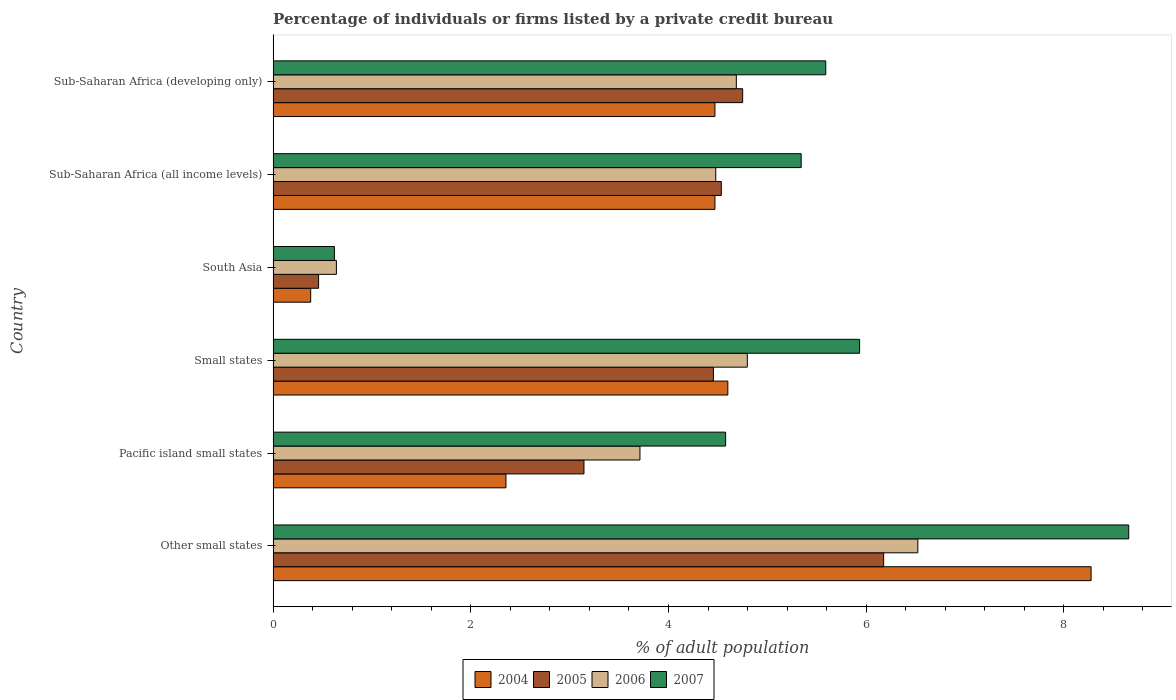How many groups of bars are there?
Your answer should be very brief. 6. How many bars are there on the 4th tick from the top?
Your answer should be compact. 4. What is the label of the 2nd group of bars from the top?
Keep it short and to the point. Sub-Saharan Africa (all income levels). In how many cases, is the number of bars for a given country not equal to the number of legend labels?
Ensure brevity in your answer.  0. What is the percentage of population listed by a private credit bureau in 2005 in Pacific island small states?
Provide a short and direct response. 3.14. Across all countries, what is the maximum percentage of population listed by a private credit bureau in 2007?
Ensure brevity in your answer.  8.66. Across all countries, what is the minimum percentage of population listed by a private credit bureau in 2007?
Your response must be concise. 0.62. In which country was the percentage of population listed by a private credit bureau in 2004 maximum?
Give a very brief answer. Other small states. In which country was the percentage of population listed by a private credit bureau in 2006 minimum?
Give a very brief answer. South Asia. What is the total percentage of population listed by a private credit bureau in 2006 in the graph?
Your answer should be compact. 24.83. What is the difference between the percentage of population listed by a private credit bureau in 2004 in Other small states and that in Sub-Saharan Africa (all income levels)?
Offer a very short reply. 3.81. What is the difference between the percentage of population listed by a private credit bureau in 2005 in Pacific island small states and the percentage of population listed by a private credit bureau in 2007 in Sub-Saharan Africa (developing only)?
Make the answer very short. -2.45. What is the average percentage of population listed by a private credit bureau in 2004 per country?
Give a very brief answer. 4.09. What is the difference between the percentage of population listed by a private credit bureau in 2007 and percentage of population listed by a private credit bureau in 2004 in Small states?
Ensure brevity in your answer.  1.33. What is the ratio of the percentage of population listed by a private credit bureau in 2007 in Sub-Saharan Africa (all income levels) to that in Sub-Saharan Africa (developing only)?
Your answer should be compact. 0.96. What is the difference between the highest and the second highest percentage of population listed by a private credit bureau in 2006?
Give a very brief answer. 1.72. What is the difference between the highest and the lowest percentage of population listed by a private credit bureau in 2007?
Provide a short and direct response. 8.04. Is the sum of the percentage of population listed by a private credit bureau in 2006 in Small states and Sub-Saharan Africa (all income levels) greater than the maximum percentage of population listed by a private credit bureau in 2005 across all countries?
Make the answer very short. Yes. Is it the case that in every country, the sum of the percentage of population listed by a private credit bureau in 2004 and percentage of population listed by a private credit bureau in 2007 is greater than the sum of percentage of population listed by a private credit bureau in 2006 and percentage of population listed by a private credit bureau in 2005?
Your answer should be compact. No. How many bars are there?
Offer a terse response. 24. How many countries are there in the graph?
Offer a very short reply. 6. What is the difference between two consecutive major ticks on the X-axis?
Ensure brevity in your answer.  2. Does the graph contain any zero values?
Your answer should be very brief. No. Where does the legend appear in the graph?
Give a very brief answer. Bottom center. How are the legend labels stacked?
Provide a short and direct response. Horizontal. What is the title of the graph?
Offer a very short reply. Percentage of individuals or firms listed by a private credit bureau. What is the label or title of the X-axis?
Offer a terse response. % of adult population. What is the % of adult population in 2004 in Other small states?
Ensure brevity in your answer.  8.28. What is the % of adult population in 2005 in Other small states?
Ensure brevity in your answer.  6.18. What is the % of adult population in 2006 in Other small states?
Your response must be concise. 6.52. What is the % of adult population in 2007 in Other small states?
Give a very brief answer. 8.66. What is the % of adult population of 2004 in Pacific island small states?
Your answer should be very brief. 2.36. What is the % of adult population of 2005 in Pacific island small states?
Give a very brief answer. 3.14. What is the % of adult population in 2006 in Pacific island small states?
Provide a short and direct response. 3.71. What is the % of adult population of 2007 in Pacific island small states?
Ensure brevity in your answer.  4.58. What is the % of adult population in 2004 in Small states?
Make the answer very short. 4.6. What is the % of adult population of 2005 in Small states?
Give a very brief answer. 4.45. What is the % of adult population of 2006 in Small states?
Provide a short and direct response. 4.8. What is the % of adult population in 2007 in Small states?
Your answer should be compact. 5.93. What is the % of adult population of 2004 in South Asia?
Your response must be concise. 0.38. What is the % of adult population of 2005 in South Asia?
Provide a succinct answer. 0.46. What is the % of adult population of 2006 in South Asia?
Ensure brevity in your answer.  0.64. What is the % of adult population of 2007 in South Asia?
Make the answer very short. 0.62. What is the % of adult population of 2004 in Sub-Saharan Africa (all income levels)?
Ensure brevity in your answer.  4.47. What is the % of adult population of 2005 in Sub-Saharan Africa (all income levels)?
Offer a very short reply. 4.53. What is the % of adult population in 2006 in Sub-Saharan Africa (all income levels)?
Your answer should be compact. 4.48. What is the % of adult population of 2007 in Sub-Saharan Africa (all income levels)?
Your answer should be very brief. 5.34. What is the % of adult population in 2004 in Sub-Saharan Africa (developing only)?
Provide a succinct answer. 4.47. What is the % of adult population of 2005 in Sub-Saharan Africa (developing only)?
Offer a terse response. 4.75. What is the % of adult population in 2006 in Sub-Saharan Africa (developing only)?
Make the answer very short. 4.69. What is the % of adult population of 2007 in Sub-Saharan Africa (developing only)?
Provide a short and direct response. 5.59. Across all countries, what is the maximum % of adult population in 2004?
Offer a terse response. 8.28. Across all countries, what is the maximum % of adult population of 2005?
Offer a terse response. 6.18. Across all countries, what is the maximum % of adult population of 2006?
Make the answer very short. 6.52. Across all countries, what is the maximum % of adult population of 2007?
Ensure brevity in your answer.  8.66. Across all countries, what is the minimum % of adult population of 2004?
Your answer should be very brief. 0.38. Across all countries, what is the minimum % of adult population of 2005?
Offer a terse response. 0.46. Across all countries, what is the minimum % of adult population of 2006?
Give a very brief answer. 0.64. Across all countries, what is the minimum % of adult population in 2007?
Keep it short and to the point. 0.62. What is the total % of adult population of 2004 in the graph?
Your response must be concise. 24.55. What is the total % of adult population of 2005 in the graph?
Provide a short and direct response. 23.52. What is the total % of adult population of 2006 in the graph?
Give a very brief answer. 24.83. What is the total % of adult population in 2007 in the graph?
Keep it short and to the point. 30.72. What is the difference between the % of adult population in 2004 in Other small states and that in Pacific island small states?
Keep it short and to the point. 5.92. What is the difference between the % of adult population in 2005 in Other small states and that in Pacific island small states?
Provide a succinct answer. 3.03. What is the difference between the % of adult population in 2006 in Other small states and that in Pacific island small states?
Provide a succinct answer. 2.81. What is the difference between the % of adult population of 2007 in Other small states and that in Pacific island small states?
Make the answer very short. 4.08. What is the difference between the % of adult population of 2004 in Other small states and that in Small states?
Your response must be concise. 3.67. What is the difference between the % of adult population of 2005 in Other small states and that in Small states?
Give a very brief answer. 1.72. What is the difference between the % of adult population in 2006 in Other small states and that in Small states?
Your answer should be very brief. 1.72. What is the difference between the % of adult population in 2007 in Other small states and that in Small states?
Provide a short and direct response. 2.72. What is the difference between the % of adult population in 2004 in Other small states and that in South Asia?
Provide a succinct answer. 7.89. What is the difference between the % of adult population of 2005 in Other small states and that in South Asia?
Your answer should be compact. 5.72. What is the difference between the % of adult population of 2006 in Other small states and that in South Asia?
Offer a very short reply. 5.88. What is the difference between the % of adult population of 2007 in Other small states and that in South Asia?
Provide a succinct answer. 8.04. What is the difference between the % of adult population in 2004 in Other small states and that in Sub-Saharan Africa (all income levels)?
Make the answer very short. 3.81. What is the difference between the % of adult population in 2005 in Other small states and that in Sub-Saharan Africa (all income levels)?
Your answer should be compact. 1.64. What is the difference between the % of adult population of 2006 in Other small states and that in Sub-Saharan Africa (all income levels)?
Offer a terse response. 2.04. What is the difference between the % of adult population of 2007 in Other small states and that in Sub-Saharan Africa (all income levels)?
Your answer should be very brief. 3.31. What is the difference between the % of adult population of 2004 in Other small states and that in Sub-Saharan Africa (developing only)?
Keep it short and to the point. 3.81. What is the difference between the % of adult population in 2005 in Other small states and that in Sub-Saharan Africa (developing only)?
Give a very brief answer. 1.43. What is the difference between the % of adult population in 2006 in Other small states and that in Sub-Saharan Africa (developing only)?
Your response must be concise. 1.84. What is the difference between the % of adult population in 2007 in Other small states and that in Sub-Saharan Africa (developing only)?
Give a very brief answer. 3.06. What is the difference between the % of adult population in 2004 in Pacific island small states and that in Small states?
Provide a succinct answer. -2.24. What is the difference between the % of adult population of 2005 in Pacific island small states and that in Small states?
Ensure brevity in your answer.  -1.31. What is the difference between the % of adult population in 2006 in Pacific island small states and that in Small states?
Your response must be concise. -1.09. What is the difference between the % of adult population of 2007 in Pacific island small states and that in Small states?
Keep it short and to the point. -1.36. What is the difference between the % of adult population of 2004 in Pacific island small states and that in South Asia?
Provide a short and direct response. 1.98. What is the difference between the % of adult population in 2005 in Pacific island small states and that in South Asia?
Make the answer very short. 2.68. What is the difference between the % of adult population in 2006 in Pacific island small states and that in South Asia?
Offer a very short reply. 3.07. What is the difference between the % of adult population of 2007 in Pacific island small states and that in South Asia?
Provide a short and direct response. 3.96. What is the difference between the % of adult population of 2004 in Pacific island small states and that in Sub-Saharan Africa (all income levels)?
Give a very brief answer. -2.11. What is the difference between the % of adult population in 2005 in Pacific island small states and that in Sub-Saharan Africa (all income levels)?
Ensure brevity in your answer.  -1.39. What is the difference between the % of adult population in 2006 in Pacific island small states and that in Sub-Saharan Africa (all income levels)?
Ensure brevity in your answer.  -0.77. What is the difference between the % of adult population in 2007 in Pacific island small states and that in Sub-Saharan Africa (all income levels)?
Provide a succinct answer. -0.76. What is the difference between the % of adult population in 2004 in Pacific island small states and that in Sub-Saharan Africa (developing only)?
Keep it short and to the point. -2.11. What is the difference between the % of adult population of 2005 in Pacific island small states and that in Sub-Saharan Africa (developing only)?
Keep it short and to the point. -1.61. What is the difference between the % of adult population of 2006 in Pacific island small states and that in Sub-Saharan Africa (developing only)?
Keep it short and to the point. -0.97. What is the difference between the % of adult population of 2007 in Pacific island small states and that in Sub-Saharan Africa (developing only)?
Your response must be concise. -1.01. What is the difference between the % of adult population in 2004 in Small states and that in South Asia?
Offer a terse response. 4.22. What is the difference between the % of adult population in 2005 in Small states and that in South Asia?
Your response must be concise. 3.99. What is the difference between the % of adult population in 2006 in Small states and that in South Asia?
Give a very brief answer. 4.16. What is the difference between the % of adult population in 2007 in Small states and that in South Asia?
Your response must be concise. 5.31. What is the difference between the % of adult population of 2004 in Small states and that in Sub-Saharan Africa (all income levels)?
Ensure brevity in your answer.  0.13. What is the difference between the % of adult population of 2005 in Small states and that in Sub-Saharan Africa (all income levels)?
Your response must be concise. -0.08. What is the difference between the % of adult population in 2006 in Small states and that in Sub-Saharan Africa (all income levels)?
Keep it short and to the point. 0.32. What is the difference between the % of adult population of 2007 in Small states and that in Sub-Saharan Africa (all income levels)?
Your response must be concise. 0.59. What is the difference between the % of adult population in 2004 in Small states and that in Sub-Saharan Africa (developing only)?
Offer a very short reply. 0.13. What is the difference between the % of adult population of 2005 in Small states and that in Sub-Saharan Africa (developing only)?
Offer a terse response. -0.3. What is the difference between the % of adult population of 2006 in Small states and that in Sub-Saharan Africa (developing only)?
Your response must be concise. 0.11. What is the difference between the % of adult population of 2007 in Small states and that in Sub-Saharan Africa (developing only)?
Your answer should be compact. 0.34. What is the difference between the % of adult population in 2004 in South Asia and that in Sub-Saharan Africa (all income levels)?
Keep it short and to the point. -4.09. What is the difference between the % of adult population in 2005 in South Asia and that in Sub-Saharan Africa (all income levels)?
Your answer should be very brief. -4.07. What is the difference between the % of adult population in 2006 in South Asia and that in Sub-Saharan Africa (all income levels)?
Your answer should be very brief. -3.84. What is the difference between the % of adult population in 2007 in South Asia and that in Sub-Saharan Africa (all income levels)?
Offer a terse response. -4.72. What is the difference between the % of adult population in 2004 in South Asia and that in Sub-Saharan Africa (developing only)?
Your response must be concise. -4.09. What is the difference between the % of adult population in 2005 in South Asia and that in Sub-Saharan Africa (developing only)?
Ensure brevity in your answer.  -4.29. What is the difference between the % of adult population of 2006 in South Asia and that in Sub-Saharan Africa (developing only)?
Your response must be concise. -4.05. What is the difference between the % of adult population of 2007 in South Asia and that in Sub-Saharan Africa (developing only)?
Offer a very short reply. -4.97. What is the difference between the % of adult population of 2004 in Sub-Saharan Africa (all income levels) and that in Sub-Saharan Africa (developing only)?
Keep it short and to the point. 0. What is the difference between the % of adult population in 2005 in Sub-Saharan Africa (all income levels) and that in Sub-Saharan Africa (developing only)?
Provide a short and direct response. -0.22. What is the difference between the % of adult population of 2006 in Sub-Saharan Africa (all income levels) and that in Sub-Saharan Africa (developing only)?
Provide a succinct answer. -0.21. What is the difference between the % of adult population in 2007 in Sub-Saharan Africa (all income levels) and that in Sub-Saharan Africa (developing only)?
Your response must be concise. -0.25. What is the difference between the % of adult population of 2004 in Other small states and the % of adult population of 2005 in Pacific island small states?
Keep it short and to the point. 5.13. What is the difference between the % of adult population of 2004 in Other small states and the % of adult population of 2006 in Pacific island small states?
Offer a very short reply. 4.56. What is the difference between the % of adult population of 2004 in Other small states and the % of adult population of 2007 in Pacific island small states?
Give a very brief answer. 3.7. What is the difference between the % of adult population of 2005 in Other small states and the % of adult population of 2006 in Pacific island small states?
Provide a succinct answer. 2.47. What is the difference between the % of adult population in 2005 in Other small states and the % of adult population in 2007 in Pacific island small states?
Provide a succinct answer. 1.6. What is the difference between the % of adult population in 2006 in Other small states and the % of adult population in 2007 in Pacific island small states?
Ensure brevity in your answer.  1.94. What is the difference between the % of adult population in 2004 in Other small states and the % of adult population in 2005 in Small states?
Provide a succinct answer. 3.82. What is the difference between the % of adult population in 2004 in Other small states and the % of adult population in 2006 in Small states?
Make the answer very short. 3.48. What is the difference between the % of adult population in 2004 in Other small states and the % of adult population in 2007 in Small states?
Give a very brief answer. 2.34. What is the difference between the % of adult population in 2005 in Other small states and the % of adult population in 2006 in Small states?
Provide a succinct answer. 1.38. What is the difference between the % of adult population of 2005 in Other small states and the % of adult population of 2007 in Small states?
Make the answer very short. 0.24. What is the difference between the % of adult population of 2006 in Other small states and the % of adult population of 2007 in Small states?
Your answer should be compact. 0.59. What is the difference between the % of adult population of 2004 in Other small states and the % of adult population of 2005 in South Asia?
Provide a succinct answer. 7.82. What is the difference between the % of adult population in 2004 in Other small states and the % of adult population in 2006 in South Asia?
Give a very brief answer. 7.63. What is the difference between the % of adult population in 2004 in Other small states and the % of adult population in 2007 in South Asia?
Provide a short and direct response. 7.66. What is the difference between the % of adult population of 2005 in Other small states and the % of adult population of 2006 in South Asia?
Give a very brief answer. 5.54. What is the difference between the % of adult population in 2005 in Other small states and the % of adult population in 2007 in South Asia?
Keep it short and to the point. 5.56. What is the difference between the % of adult population of 2006 in Other small states and the % of adult population of 2007 in South Asia?
Offer a terse response. 5.9. What is the difference between the % of adult population in 2004 in Other small states and the % of adult population in 2005 in Sub-Saharan Africa (all income levels)?
Offer a terse response. 3.74. What is the difference between the % of adult population of 2004 in Other small states and the % of adult population of 2006 in Sub-Saharan Africa (all income levels)?
Offer a terse response. 3.8. What is the difference between the % of adult population of 2004 in Other small states and the % of adult population of 2007 in Sub-Saharan Africa (all income levels)?
Give a very brief answer. 2.93. What is the difference between the % of adult population in 2005 in Other small states and the % of adult population in 2006 in Sub-Saharan Africa (all income levels)?
Your answer should be compact. 1.7. What is the difference between the % of adult population in 2005 in Other small states and the % of adult population in 2007 in Sub-Saharan Africa (all income levels)?
Make the answer very short. 0.83. What is the difference between the % of adult population of 2006 in Other small states and the % of adult population of 2007 in Sub-Saharan Africa (all income levels)?
Your response must be concise. 1.18. What is the difference between the % of adult population in 2004 in Other small states and the % of adult population in 2005 in Sub-Saharan Africa (developing only)?
Ensure brevity in your answer.  3.52. What is the difference between the % of adult population in 2004 in Other small states and the % of adult population in 2006 in Sub-Saharan Africa (developing only)?
Offer a very short reply. 3.59. What is the difference between the % of adult population in 2004 in Other small states and the % of adult population in 2007 in Sub-Saharan Africa (developing only)?
Your response must be concise. 2.68. What is the difference between the % of adult population of 2005 in Other small states and the % of adult population of 2006 in Sub-Saharan Africa (developing only)?
Make the answer very short. 1.49. What is the difference between the % of adult population in 2005 in Other small states and the % of adult population in 2007 in Sub-Saharan Africa (developing only)?
Provide a succinct answer. 0.59. What is the difference between the % of adult population in 2006 in Other small states and the % of adult population in 2007 in Sub-Saharan Africa (developing only)?
Make the answer very short. 0.93. What is the difference between the % of adult population of 2004 in Pacific island small states and the % of adult population of 2005 in Small states?
Ensure brevity in your answer.  -2.1. What is the difference between the % of adult population of 2004 in Pacific island small states and the % of adult population of 2006 in Small states?
Give a very brief answer. -2.44. What is the difference between the % of adult population of 2004 in Pacific island small states and the % of adult population of 2007 in Small states?
Ensure brevity in your answer.  -3.58. What is the difference between the % of adult population in 2005 in Pacific island small states and the % of adult population in 2006 in Small states?
Keep it short and to the point. -1.65. What is the difference between the % of adult population of 2005 in Pacific island small states and the % of adult population of 2007 in Small states?
Provide a succinct answer. -2.79. What is the difference between the % of adult population of 2006 in Pacific island small states and the % of adult population of 2007 in Small states?
Your response must be concise. -2.22. What is the difference between the % of adult population of 2004 in Pacific island small states and the % of adult population of 2005 in South Asia?
Your response must be concise. 1.9. What is the difference between the % of adult population of 2004 in Pacific island small states and the % of adult population of 2006 in South Asia?
Your answer should be compact. 1.72. What is the difference between the % of adult population of 2004 in Pacific island small states and the % of adult population of 2007 in South Asia?
Offer a very short reply. 1.74. What is the difference between the % of adult population in 2005 in Pacific island small states and the % of adult population in 2006 in South Asia?
Make the answer very short. 2.5. What is the difference between the % of adult population of 2005 in Pacific island small states and the % of adult population of 2007 in South Asia?
Your response must be concise. 2.52. What is the difference between the % of adult population in 2006 in Pacific island small states and the % of adult population in 2007 in South Asia?
Your answer should be very brief. 3.09. What is the difference between the % of adult population in 2004 in Pacific island small states and the % of adult population in 2005 in Sub-Saharan Africa (all income levels)?
Give a very brief answer. -2.18. What is the difference between the % of adult population in 2004 in Pacific island small states and the % of adult population in 2006 in Sub-Saharan Africa (all income levels)?
Keep it short and to the point. -2.12. What is the difference between the % of adult population in 2004 in Pacific island small states and the % of adult population in 2007 in Sub-Saharan Africa (all income levels)?
Provide a short and direct response. -2.99. What is the difference between the % of adult population in 2005 in Pacific island small states and the % of adult population in 2006 in Sub-Saharan Africa (all income levels)?
Provide a succinct answer. -1.33. What is the difference between the % of adult population of 2005 in Pacific island small states and the % of adult population of 2007 in Sub-Saharan Africa (all income levels)?
Ensure brevity in your answer.  -2.2. What is the difference between the % of adult population of 2006 in Pacific island small states and the % of adult population of 2007 in Sub-Saharan Africa (all income levels)?
Give a very brief answer. -1.63. What is the difference between the % of adult population of 2004 in Pacific island small states and the % of adult population of 2005 in Sub-Saharan Africa (developing only)?
Your response must be concise. -2.39. What is the difference between the % of adult population in 2004 in Pacific island small states and the % of adult population in 2006 in Sub-Saharan Africa (developing only)?
Keep it short and to the point. -2.33. What is the difference between the % of adult population in 2004 in Pacific island small states and the % of adult population in 2007 in Sub-Saharan Africa (developing only)?
Your answer should be compact. -3.24. What is the difference between the % of adult population in 2005 in Pacific island small states and the % of adult population in 2006 in Sub-Saharan Africa (developing only)?
Make the answer very short. -1.54. What is the difference between the % of adult population of 2005 in Pacific island small states and the % of adult population of 2007 in Sub-Saharan Africa (developing only)?
Ensure brevity in your answer.  -2.45. What is the difference between the % of adult population in 2006 in Pacific island small states and the % of adult population in 2007 in Sub-Saharan Africa (developing only)?
Provide a short and direct response. -1.88. What is the difference between the % of adult population in 2004 in Small states and the % of adult population in 2005 in South Asia?
Your answer should be very brief. 4.14. What is the difference between the % of adult population in 2004 in Small states and the % of adult population in 2006 in South Asia?
Offer a very short reply. 3.96. What is the difference between the % of adult population in 2004 in Small states and the % of adult population in 2007 in South Asia?
Give a very brief answer. 3.98. What is the difference between the % of adult population in 2005 in Small states and the % of adult population in 2006 in South Asia?
Your response must be concise. 3.81. What is the difference between the % of adult population in 2005 in Small states and the % of adult population in 2007 in South Asia?
Offer a terse response. 3.83. What is the difference between the % of adult population in 2006 in Small states and the % of adult population in 2007 in South Asia?
Provide a succinct answer. 4.18. What is the difference between the % of adult population of 2004 in Small states and the % of adult population of 2005 in Sub-Saharan Africa (all income levels)?
Offer a terse response. 0.07. What is the difference between the % of adult population in 2004 in Small states and the % of adult population in 2006 in Sub-Saharan Africa (all income levels)?
Give a very brief answer. 0.12. What is the difference between the % of adult population of 2004 in Small states and the % of adult population of 2007 in Sub-Saharan Africa (all income levels)?
Offer a very short reply. -0.74. What is the difference between the % of adult population in 2005 in Small states and the % of adult population in 2006 in Sub-Saharan Africa (all income levels)?
Provide a short and direct response. -0.02. What is the difference between the % of adult population in 2005 in Small states and the % of adult population in 2007 in Sub-Saharan Africa (all income levels)?
Keep it short and to the point. -0.89. What is the difference between the % of adult population in 2006 in Small states and the % of adult population in 2007 in Sub-Saharan Africa (all income levels)?
Your answer should be very brief. -0.54. What is the difference between the % of adult population in 2004 in Small states and the % of adult population in 2005 in Sub-Saharan Africa (developing only)?
Make the answer very short. -0.15. What is the difference between the % of adult population of 2004 in Small states and the % of adult population of 2006 in Sub-Saharan Africa (developing only)?
Make the answer very short. -0.09. What is the difference between the % of adult population of 2004 in Small states and the % of adult population of 2007 in Sub-Saharan Africa (developing only)?
Provide a short and direct response. -0.99. What is the difference between the % of adult population of 2005 in Small states and the % of adult population of 2006 in Sub-Saharan Africa (developing only)?
Offer a very short reply. -0.23. What is the difference between the % of adult population of 2005 in Small states and the % of adult population of 2007 in Sub-Saharan Africa (developing only)?
Offer a very short reply. -1.14. What is the difference between the % of adult population of 2006 in Small states and the % of adult population of 2007 in Sub-Saharan Africa (developing only)?
Your answer should be very brief. -0.79. What is the difference between the % of adult population of 2004 in South Asia and the % of adult population of 2005 in Sub-Saharan Africa (all income levels)?
Keep it short and to the point. -4.15. What is the difference between the % of adult population in 2004 in South Asia and the % of adult population in 2006 in Sub-Saharan Africa (all income levels)?
Make the answer very short. -4.1. What is the difference between the % of adult population in 2004 in South Asia and the % of adult population in 2007 in Sub-Saharan Africa (all income levels)?
Your answer should be compact. -4.96. What is the difference between the % of adult population in 2005 in South Asia and the % of adult population in 2006 in Sub-Saharan Africa (all income levels)?
Make the answer very short. -4.02. What is the difference between the % of adult population in 2005 in South Asia and the % of adult population in 2007 in Sub-Saharan Africa (all income levels)?
Your response must be concise. -4.88. What is the difference between the % of adult population of 2006 in South Asia and the % of adult population of 2007 in Sub-Saharan Africa (all income levels)?
Offer a very short reply. -4.7. What is the difference between the % of adult population of 2004 in South Asia and the % of adult population of 2005 in Sub-Saharan Africa (developing only)?
Provide a succinct answer. -4.37. What is the difference between the % of adult population in 2004 in South Asia and the % of adult population in 2006 in Sub-Saharan Africa (developing only)?
Your response must be concise. -4.31. What is the difference between the % of adult population of 2004 in South Asia and the % of adult population of 2007 in Sub-Saharan Africa (developing only)?
Your answer should be very brief. -5.21. What is the difference between the % of adult population in 2005 in South Asia and the % of adult population in 2006 in Sub-Saharan Africa (developing only)?
Give a very brief answer. -4.23. What is the difference between the % of adult population of 2005 in South Asia and the % of adult population of 2007 in Sub-Saharan Africa (developing only)?
Offer a terse response. -5.13. What is the difference between the % of adult population in 2006 in South Asia and the % of adult population in 2007 in Sub-Saharan Africa (developing only)?
Keep it short and to the point. -4.95. What is the difference between the % of adult population in 2004 in Sub-Saharan Africa (all income levels) and the % of adult population in 2005 in Sub-Saharan Africa (developing only)?
Ensure brevity in your answer.  -0.28. What is the difference between the % of adult population of 2004 in Sub-Saharan Africa (all income levels) and the % of adult population of 2006 in Sub-Saharan Africa (developing only)?
Provide a succinct answer. -0.22. What is the difference between the % of adult population of 2004 in Sub-Saharan Africa (all income levels) and the % of adult population of 2007 in Sub-Saharan Africa (developing only)?
Offer a very short reply. -1.12. What is the difference between the % of adult population of 2005 in Sub-Saharan Africa (all income levels) and the % of adult population of 2006 in Sub-Saharan Africa (developing only)?
Offer a terse response. -0.15. What is the difference between the % of adult population of 2005 in Sub-Saharan Africa (all income levels) and the % of adult population of 2007 in Sub-Saharan Africa (developing only)?
Provide a short and direct response. -1.06. What is the difference between the % of adult population in 2006 in Sub-Saharan Africa (all income levels) and the % of adult population in 2007 in Sub-Saharan Africa (developing only)?
Ensure brevity in your answer.  -1.11. What is the average % of adult population in 2004 per country?
Provide a succinct answer. 4.09. What is the average % of adult population in 2005 per country?
Keep it short and to the point. 3.92. What is the average % of adult population in 2006 per country?
Provide a short and direct response. 4.14. What is the average % of adult population in 2007 per country?
Give a very brief answer. 5.12. What is the difference between the % of adult population of 2004 and % of adult population of 2005 in Other small states?
Make the answer very short. 2.1. What is the difference between the % of adult population of 2004 and % of adult population of 2006 in Other small states?
Keep it short and to the point. 1.75. What is the difference between the % of adult population of 2004 and % of adult population of 2007 in Other small states?
Your answer should be compact. -0.38. What is the difference between the % of adult population of 2005 and % of adult population of 2006 in Other small states?
Make the answer very short. -0.35. What is the difference between the % of adult population of 2005 and % of adult population of 2007 in Other small states?
Provide a succinct answer. -2.48. What is the difference between the % of adult population of 2006 and % of adult population of 2007 in Other small states?
Ensure brevity in your answer.  -2.13. What is the difference between the % of adult population of 2004 and % of adult population of 2005 in Pacific island small states?
Your response must be concise. -0.79. What is the difference between the % of adult population in 2004 and % of adult population in 2006 in Pacific island small states?
Provide a succinct answer. -1.36. What is the difference between the % of adult population of 2004 and % of adult population of 2007 in Pacific island small states?
Keep it short and to the point. -2.22. What is the difference between the % of adult population in 2005 and % of adult population in 2006 in Pacific island small states?
Provide a short and direct response. -0.57. What is the difference between the % of adult population of 2005 and % of adult population of 2007 in Pacific island small states?
Ensure brevity in your answer.  -1.43. What is the difference between the % of adult population of 2006 and % of adult population of 2007 in Pacific island small states?
Offer a terse response. -0.87. What is the difference between the % of adult population of 2004 and % of adult population of 2005 in Small states?
Ensure brevity in your answer.  0.15. What is the difference between the % of adult population in 2004 and % of adult population in 2006 in Small states?
Offer a very short reply. -0.2. What is the difference between the % of adult population of 2004 and % of adult population of 2007 in Small states?
Give a very brief answer. -1.33. What is the difference between the % of adult population in 2005 and % of adult population in 2006 in Small states?
Your answer should be very brief. -0.34. What is the difference between the % of adult population of 2005 and % of adult population of 2007 in Small states?
Your response must be concise. -1.48. What is the difference between the % of adult population of 2006 and % of adult population of 2007 in Small states?
Your response must be concise. -1.14. What is the difference between the % of adult population in 2004 and % of adult population in 2005 in South Asia?
Make the answer very short. -0.08. What is the difference between the % of adult population of 2004 and % of adult population of 2006 in South Asia?
Offer a terse response. -0.26. What is the difference between the % of adult population of 2004 and % of adult population of 2007 in South Asia?
Your answer should be very brief. -0.24. What is the difference between the % of adult population in 2005 and % of adult population in 2006 in South Asia?
Give a very brief answer. -0.18. What is the difference between the % of adult population of 2005 and % of adult population of 2007 in South Asia?
Make the answer very short. -0.16. What is the difference between the % of adult population in 2006 and % of adult population in 2007 in South Asia?
Give a very brief answer. 0.02. What is the difference between the % of adult population in 2004 and % of adult population in 2005 in Sub-Saharan Africa (all income levels)?
Provide a succinct answer. -0.06. What is the difference between the % of adult population in 2004 and % of adult population in 2006 in Sub-Saharan Africa (all income levels)?
Provide a short and direct response. -0.01. What is the difference between the % of adult population of 2004 and % of adult population of 2007 in Sub-Saharan Africa (all income levels)?
Keep it short and to the point. -0.87. What is the difference between the % of adult population in 2005 and % of adult population in 2006 in Sub-Saharan Africa (all income levels)?
Your answer should be compact. 0.06. What is the difference between the % of adult population of 2005 and % of adult population of 2007 in Sub-Saharan Africa (all income levels)?
Ensure brevity in your answer.  -0.81. What is the difference between the % of adult population of 2006 and % of adult population of 2007 in Sub-Saharan Africa (all income levels)?
Provide a succinct answer. -0.86. What is the difference between the % of adult population in 2004 and % of adult population in 2005 in Sub-Saharan Africa (developing only)?
Offer a very short reply. -0.28. What is the difference between the % of adult population in 2004 and % of adult population in 2006 in Sub-Saharan Africa (developing only)?
Ensure brevity in your answer.  -0.22. What is the difference between the % of adult population in 2004 and % of adult population in 2007 in Sub-Saharan Africa (developing only)?
Make the answer very short. -1.12. What is the difference between the % of adult population of 2005 and % of adult population of 2006 in Sub-Saharan Africa (developing only)?
Your answer should be compact. 0.06. What is the difference between the % of adult population of 2005 and % of adult population of 2007 in Sub-Saharan Africa (developing only)?
Offer a very short reply. -0.84. What is the difference between the % of adult population in 2006 and % of adult population in 2007 in Sub-Saharan Africa (developing only)?
Your answer should be compact. -0.9. What is the ratio of the % of adult population in 2004 in Other small states to that in Pacific island small states?
Keep it short and to the point. 3.51. What is the ratio of the % of adult population of 2005 in Other small states to that in Pacific island small states?
Provide a succinct answer. 1.96. What is the ratio of the % of adult population of 2006 in Other small states to that in Pacific island small states?
Keep it short and to the point. 1.76. What is the ratio of the % of adult population in 2007 in Other small states to that in Pacific island small states?
Your answer should be very brief. 1.89. What is the ratio of the % of adult population in 2004 in Other small states to that in Small states?
Ensure brevity in your answer.  1.8. What is the ratio of the % of adult population of 2005 in Other small states to that in Small states?
Your answer should be compact. 1.39. What is the ratio of the % of adult population in 2006 in Other small states to that in Small states?
Make the answer very short. 1.36. What is the ratio of the % of adult population in 2007 in Other small states to that in Small states?
Ensure brevity in your answer.  1.46. What is the ratio of the % of adult population in 2004 in Other small states to that in South Asia?
Make the answer very short. 21.78. What is the ratio of the % of adult population of 2005 in Other small states to that in South Asia?
Make the answer very short. 13.43. What is the ratio of the % of adult population in 2006 in Other small states to that in South Asia?
Offer a terse response. 10.19. What is the ratio of the % of adult population of 2007 in Other small states to that in South Asia?
Your response must be concise. 13.96. What is the ratio of the % of adult population of 2004 in Other small states to that in Sub-Saharan Africa (all income levels)?
Give a very brief answer. 1.85. What is the ratio of the % of adult population in 2005 in Other small states to that in Sub-Saharan Africa (all income levels)?
Offer a very short reply. 1.36. What is the ratio of the % of adult population of 2006 in Other small states to that in Sub-Saharan Africa (all income levels)?
Keep it short and to the point. 1.46. What is the ratio of the % of adult population in 2007 in Other small states to that in Sub-Saharan Africa (all income levels)?
Keep it short and to the point. 1.62. What is the ratio of the % of adult population in 2004 in Other small states to that in Sub-Saharan Africa (developing only)?
Provide a short and direct response. 1.85. What is the ratio of the % of adult population in 2005 in Other small states to that in Sub-Saharan Africa (developing only)?
Your response must be concise. 1.3. What is the ratio of the % of adult population of 2006 in Other small states to that in Sub-Saharan Africa (developing only)?
Provide a succinct answer. 1.39. What is the ratio of the % of adult population in 2007 in Other small states to that in Sub-Saharan Africa (developing only)?
Ensure brevity in your answer.  1.55. What is the ratio of the % of adult population in 2004 in Pacific island small states to that in Small states?
Provide a short and direct response. 0.51. What is the ratio of the % of adult population of 2005 in Pacific island small states to that in Small states?
Your response must be concise. 0.71. What is the ratio of the % of adult population in 2006 in Pacific island small states to that in Small states?
Make the answer very short. 0.77. What is the ratio of the % of adult population of 2007 in Pacific island small states to that in Small states?
Give a very brief answer. 0.77. What is the ratio of the % of adult population in 2004 in Pacific island small states to that in South Asia?
Your answer should be very brief. 6.2. What is the ratio of the % of adult population in 2005 in Pacific island small states to that in South Asia?
Make the answer very short. 6.84. What is the ratio of the % of adult population of 2006 in Pacific island small states to that in South Asia?
Your answer should be very brief. 5.8. What is the ratio of the % of adult population in 2007 in Pacific island small states to that in South Asia?
Your answer should be very brief. 7.38. What is the ratio of the % of adult population in 2004 in Pacific island small states to that in Sub-Saharan Africa (all income levels)?
Provide a short and direct response. 0.53. What is the ratio of the % of adult population in 2005 in Pacific island small states to that in Sub-Saharan Africa (all income levels)?
Offer a very short reply. 0.69. What is the ratio of the % of adult population of 2006 in Pacific island small states to that in Sub-Saharan Africa (all income levels)?
Keep it short and to the point. 0.83. What is the ratio of the % of adult population in 2007 in Pacific island small states to that in Sub-Saharan Africa (all income levels)?
Provide a succinct answer. 0.86. What is the ratio of the % of adult population in 2004 in Pacific island small states to that in Sub-Saharan Africa (developing only)?
Keep it short and to the point. 0.53. What is the ratio of the % of adult population of 2005 in Pacific island small states to that in Sub-Saharan Africa (developing only)?
Provide a short and direct response. 0.66. What is the ratio of the % of adult population in 2006 in Pacific island small states to that in Sub-Saharan Africa (developing only)?
Your response must be concise. 0.79. What is the ratio of the % of adult population of 2007 in Pacific island small states to that in Sub-Saharan Africa (developing only)?
Provide a succinct answer. 0.82. What is the ratio of the % of adult population of 2004 in Small states to that in South Asia?
Ensure brevity in your answer.  12.11. What is the ratio of the % of adult population of 2005 in Small states to that in South Asia?
Your answer should be very brief. 9.68. What is the ratio of the % of adult population of 2006 in Small states to that in South Asia?
Offer a very short reply. 7.5. What is the ratio of the % of adult population in 2007 in Small states to that in South Asia?
Keep it short and to the point. 9.57. What is the ratio of the % of adult population in 2004 in Small states to that in Sub-Saharan Africa (all income levels)?
Offer a terse response. 1.03. What is the ratio of the % of adult population of 2005 in Small states to that in Sub-Saharan Africa (all income levels)?
Ensure brevity in your answer.  0.98. What is the ratio of the % of adult population in 2006 in Small states to that in Sub-Saharan Africa (all income levels)?
Give a very brief answer. 1.07. What is the ratio of the % of adult population of 2007 in Small states to that in Sub-Saharan Africa (all income levels)?
Offer a terse response. 1.11. What is the ratio of the % of adult population in 2004 in Small states to that in Sub-Saharan Africa (developing only)?
Provide a succinct answer. 1.03. What is the ratio of the % of adult population in 2005 in Small states to that in Sub-Saharan Africa (developing only)?
Provide a succinct answer. 0.94. What is the ratio of the % of adult population in 2006 in Small states to that in Sub-Saharan Africa (developing only)?
Your response must be concise. 1.02. What is the ratio of the % of adult population in 2007 in Small states to that in Sub-Saharan Africa (developing only)?
Ensure brevity in your answer.  1.06. What is the ratio of the % of adult population in 2004 in South Asia to that in Sub-Saharan Africa (all income levels)?
Make the answer very short. 0.09. What is the ratio of the % of adult population of 2005 in South Asia to that in Sub-Saharan Africa (all income levels)?
Make the answer very short. 0.1. What is the ratio of the % of adult population in 2006 in South Asia to that in Sub-Saharan Africa (all income levels)?
Your answer should be compact. 0.14. What is the ratio of the % of adult population in 2007 in South Asia to that in Sub-Saharan Africa (all income levels)?
Your response must be concise. 0.12. What is the ratio of the % of adult population in 2004 in South Asia to that in Sub-Saharan Africa (developing only)?
Your response must be concise. 0.09. What is the ratio of the % of adult population of 2005 in South Asia to that in Sub-Saharan Africa (developing only)?
Give a very brief answer. 0.1. What is the ratio of the % of adult population of 2006 in South Asia to that in Sub-Saharan Africa (developing only)?
Give a very brief answer. 0.14. What is the ratio of the % of adult population in 2007 in South Asia to that in Sub-Saharan Africa (developing only)?
Give a very brief answer. 0.11. What is the ratio of the % of adult population in 2005 in Sub-Saharan Africa (all income levels) to that in Sub-Saharan Africa (developing only)?
Provide a succinct answer. 0.95. What is the ratio of the % of adult population of 2006 in Sub-Saharan Africa (all income levels) to that in Sub-Saharan Africa (developing only)?
Give a very brief answer. 0.96. What is the ratio of the % of adult population in 2007 in Sub-Saharan Africa (all income levels) to that in Sub-Saharan Africa (developing only)?
Ensure brevity in your answer.  0.96. What is the difference between the highest and the second highest % of adult population of 2004?
Provide a succinct answer. 3.67. What is the difference between the highest and the second highest % of adult population in 2005?
Give a very brief answer. 1.43. What is the difference between the highest and the second highest % of adult population in 2006?
Your response must be concise. 1.72. What is the difference between the highest and the second highest % of adult population of 2007?
Provide a short and direct response. 2.72. What is the difference between the highest and the lowest % of adult population in 2004?
Offer a very short reply. 7.89. What is the difference between the highest and the lowest % of adult population of 2005?
Provide a short and direct response. 5.72. What is the difference between the highest and the lowest % of adult population in 2006?
Make the answer very short. 5.88. What is the difference between the highest and the lowest % of adult population in 2007?
Keep it short and to the point. 8.04. 